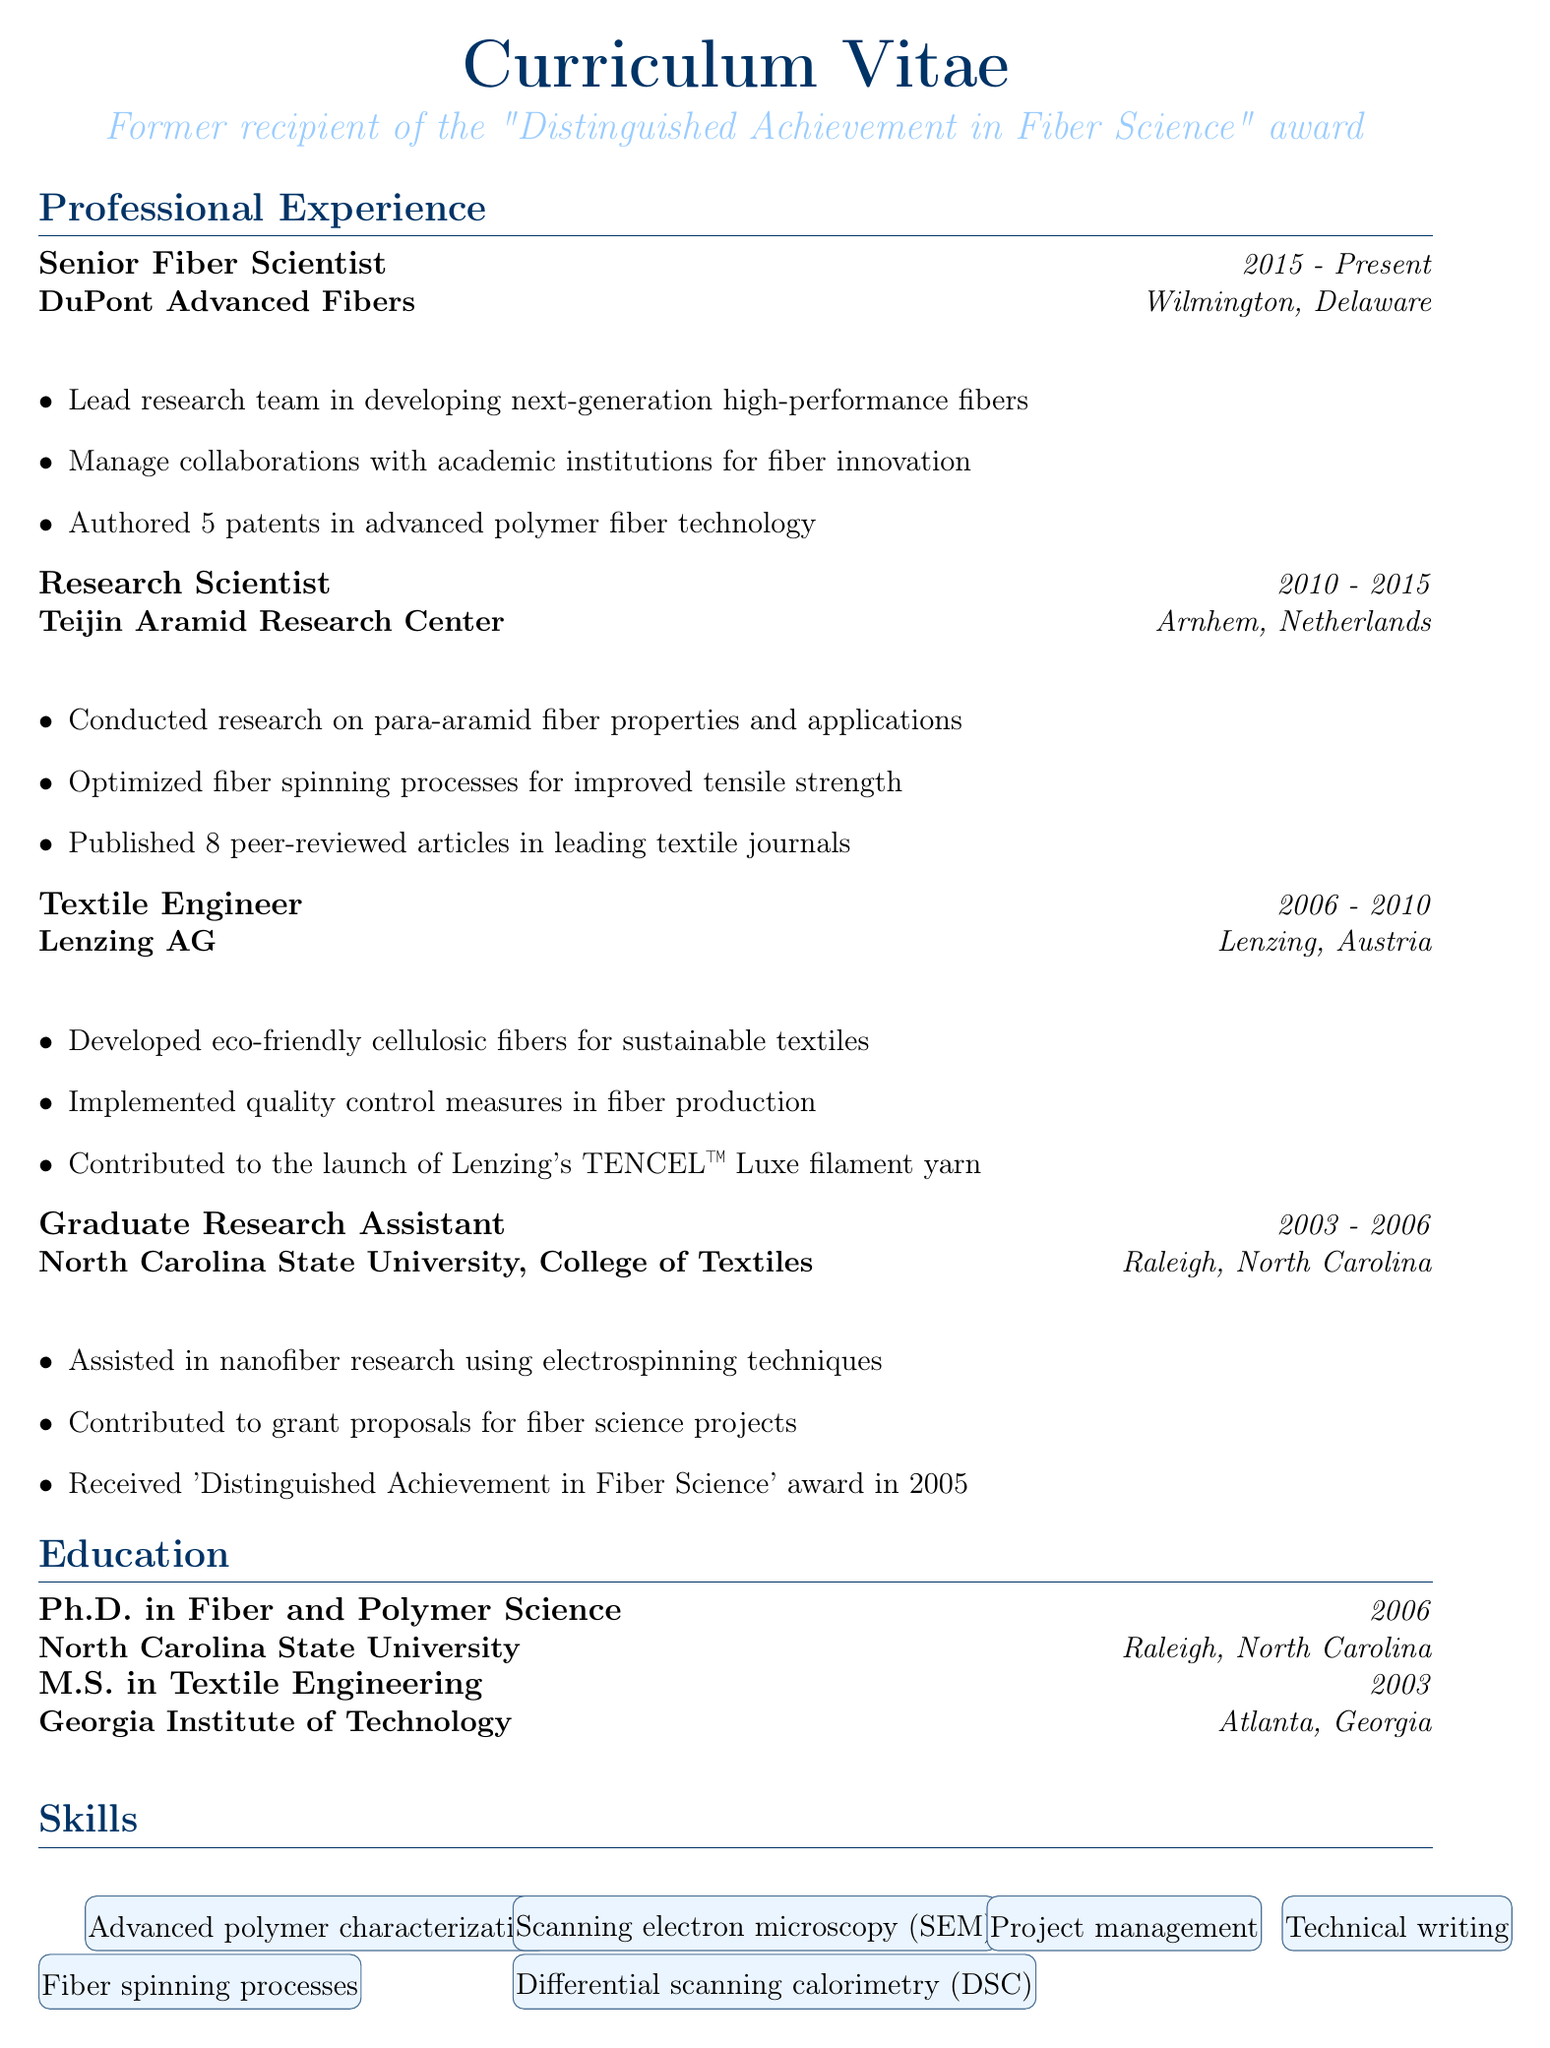What is the title of the current position? The title of the current position is listed at the top of the professional experiences section.
Answer: Senior Fiber Scientist In which location does the current job take place? The location of the current job is specified in the professional experience section.
Answer: Wilmington, Delaware What year did the individual receive their Ph.D.? The year of the Ph.D. is noted in the education section of the document.
Answer: 2006 How many patents has the individual authored? The number of patents authored is mentioned in the responsibilities of the current position.
Answer: 5 patents What was a key responsibility of the Textile Engineer role? This responsibility is provided in the professional experiences section under the Textile Engineer role.
Answer: Developed eco-friendly cellulosic fibers for sustainable textiles Which award did the individual receive in 2005? The award received is mentioned in the responsibilities of the Graduate Research Assistant position.
Answer: Distinguished Achievement in Fiber Science How many peer-reviewed articles were published during the Research Scientist role? The number of published articles is listed in the responsibilities of the Research Scientist position.
Answer: 8 peer-reviewed articles What type of fibers is the focus of the current research team's work? The focus of the research team's work is specified in the leading responsibility of the current position.
Answer: High-performance fibers 